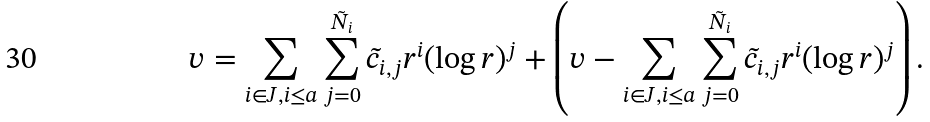<formula> <loc_0><loc_0><loc_500><loc_500>v = \sum _ { i \in J , i \leq a } \sum _ { j = 0 } ^ { \tilde { N } _ { i } } \tilde { c } _ { i , j } r ^ { i } ( \log r ) ^ { j } + \left ( v - \sum _ { i \in J , i \leq a } \sum _ { j = 0 } ^ { \tilde { N } _ { i } } \tilde { c } _ { i , j } r ^ { i } ( \log r ) ^ { j } \right ) .</formula> 